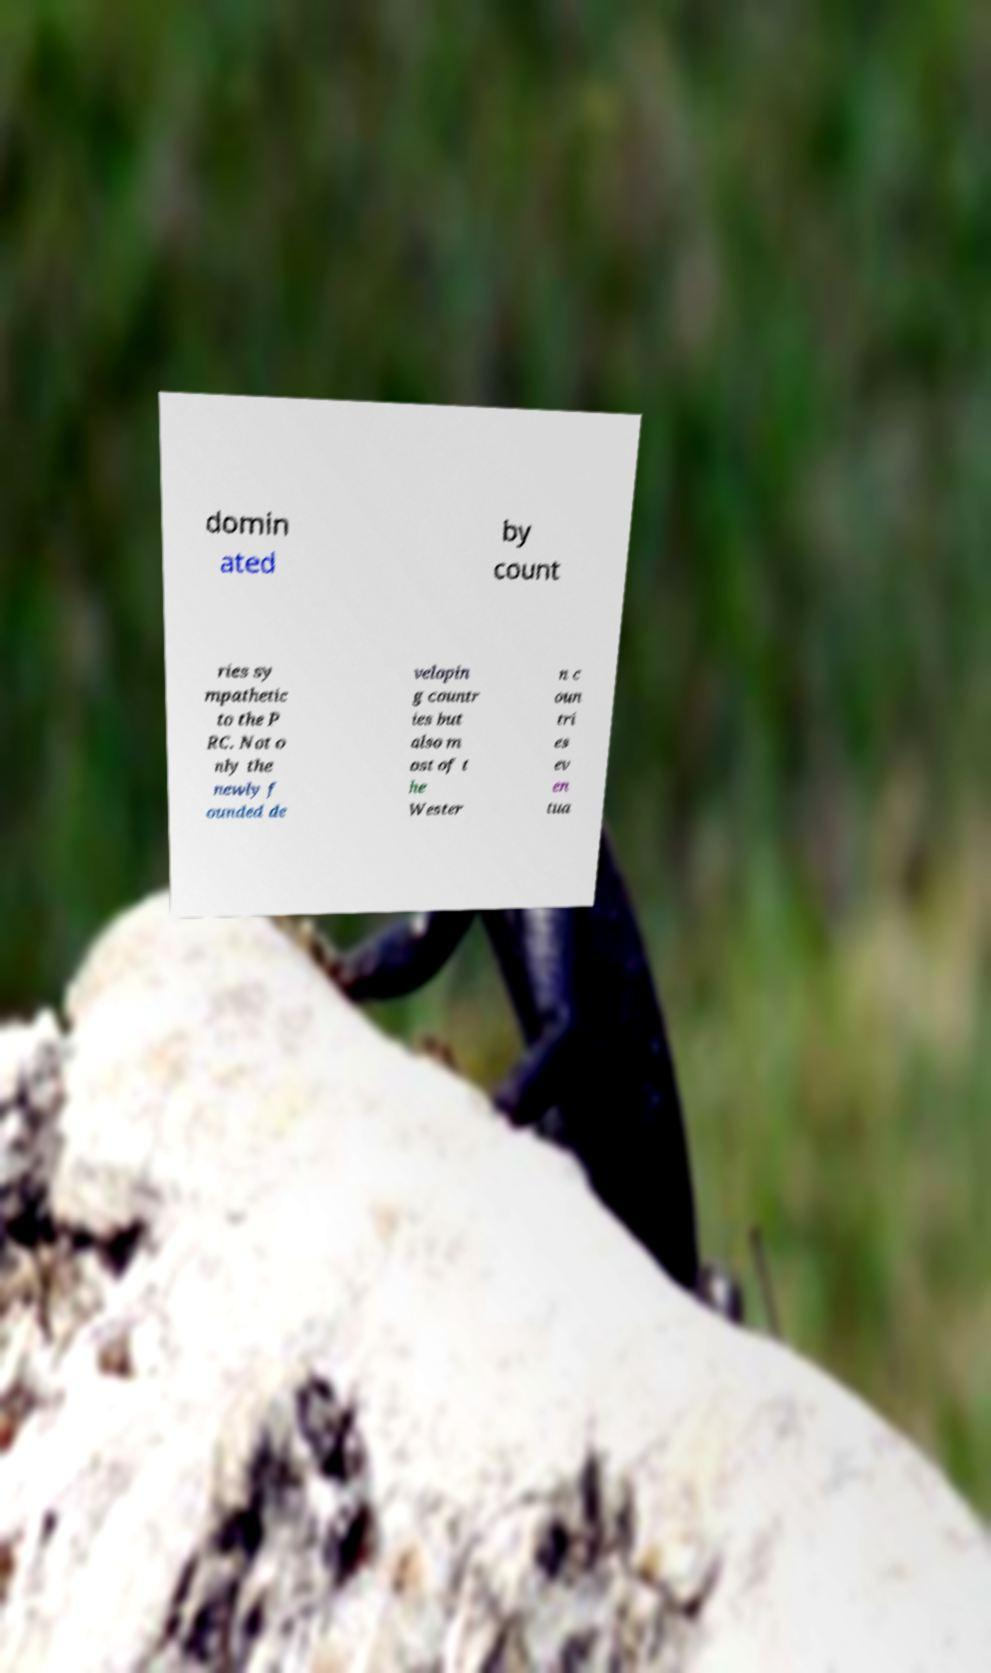Could you assist in decoding the text presented in this image and type it out clearly? domin ated by count ries sy mpathetic to the P RC. Not o nly the newly f ounded de velopin g countr ies but also m ost of t he Wester n c oun tri es ev en tua 